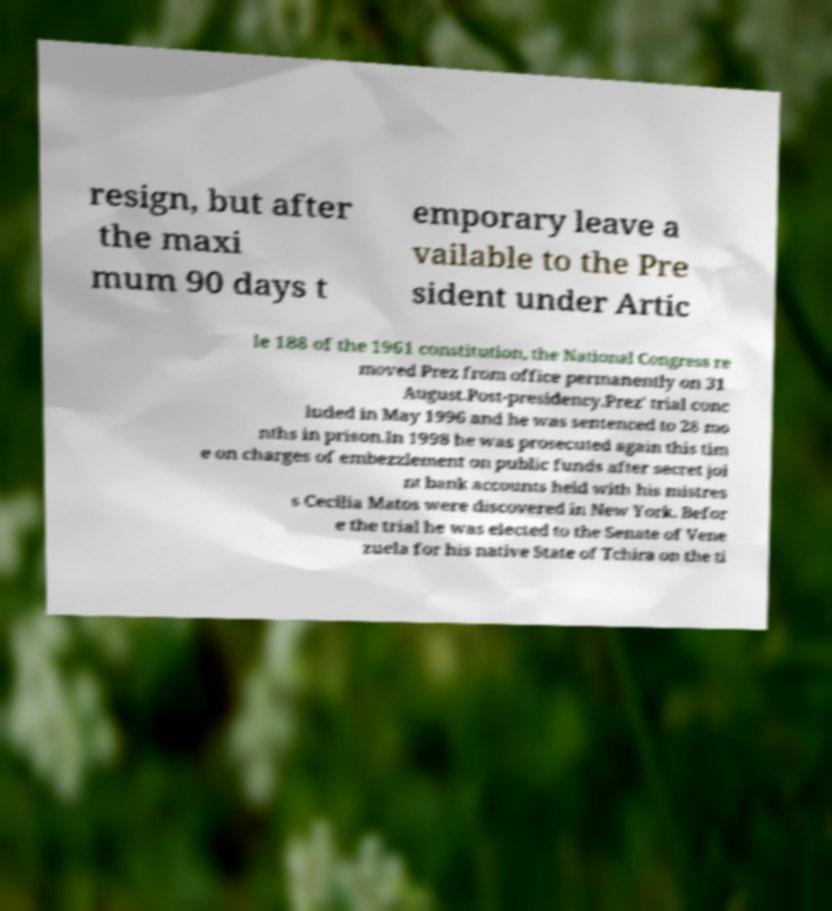Can you read and provide the text displayed in the image?This photo seems to have some interesting text. Can you extract and type it out for me? resign, but after the maxi mum 90 days t emporary leave a vailable to the Pre sident under Artic le 188 of the 1961 constitution, the National Congress re moved Prez from office permanently on 31 August.Post-presidency.Prez' trial conc luded in May 1996 and he was sentenced to 28 mo nths in prison.In 1998 he was prosecuted again this tim e on charges of embezzlement on public funds after secret joi nt bank accounts held with his mistres s Cecilia Matos were discovered in New York. Befor e the trial he was elected to the Senate of Vene zuela for his native State of Tchira on the ti 